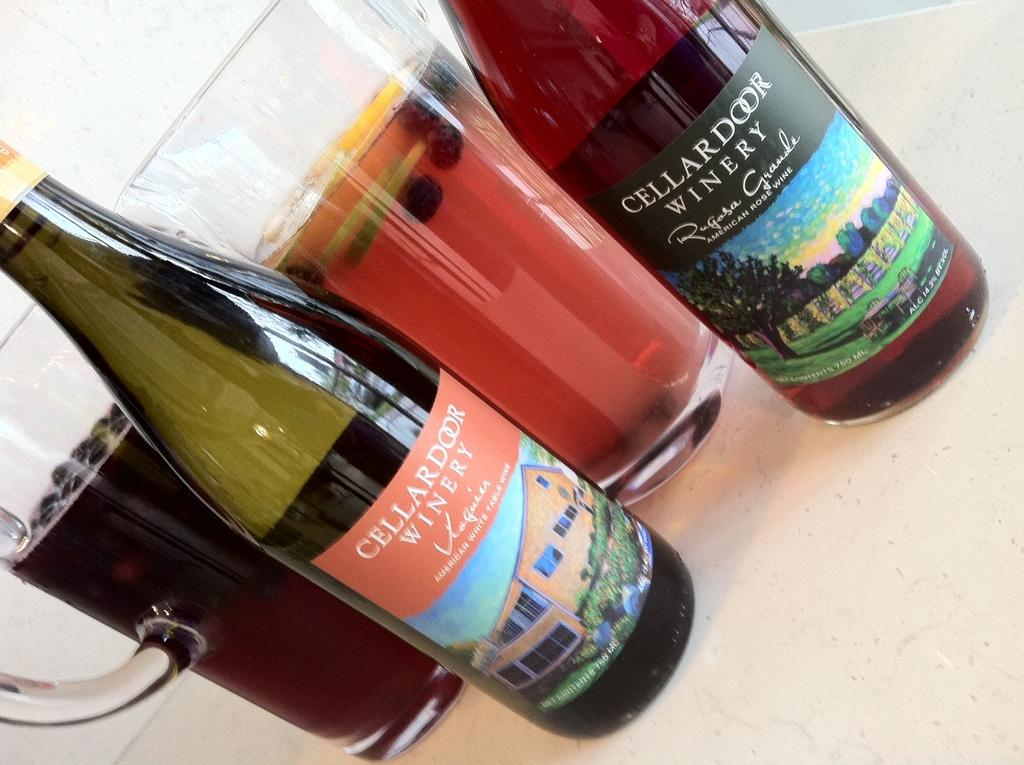<image>
Render a clear and concise summary of the photo. Two bottles from the Cellar Door Winery are together on a table. 